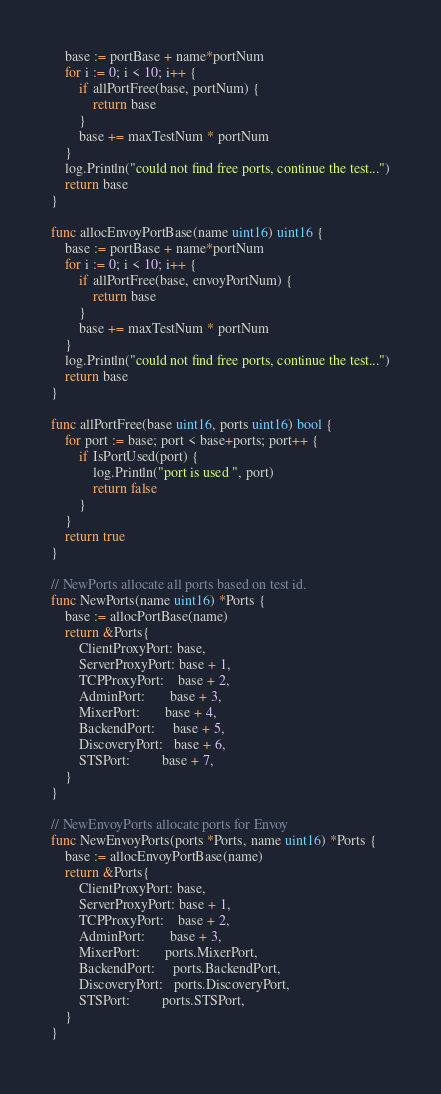Convert code to text. <code><loc_0><loc_0><loc_500><loc_500><_Go_>	base := portBase + name*portNum
	for i := 0; i < 10; i++ {
		if allPortFree(base, portNum) {
			return base
		}
		base += maxTestNum * portNum
	}
	log.Println("could not find free ports, continue the test...")
	return base
}

func allocEnvoyPortBase(name uint16) uint16 {
	base := portBase + name*portNum
	for i := 0; i < 10; i++ {
		if allPortFree(base, envoyPortNum) {
			return base
		}
		base += maxTestNum * portNum
	}
	log.Println("could not find free ports, continue the test...")
	return base
}

func allPortFree(base uint16, ports uint16) bool {
	for port := base; port < base+ports; port++ {
		if IsPortUsed(port) {
			log.Println("port is used ", port)
			return false
		}
	}
	return true
}

// NewPorts allocate all ports based on test id.
func NewPorts(name uint16) *Ports {
	base := allocPortBase(name)
	return &Ports{
		ClientProxyPort: base,
		ServerProxyPort: base + 1,
		TCPProxyPort:    base + 2,
		AdminPort:       base + 3,
		MixerPort:       base + 4,
		BackendPort:     base + 5,
		DiscoveryPort:   base + 6,
		STSPort:         base + 7,
	}
}

// NewEnvoyPorts allocate ports for Envoy
func NewEnvoyPorts(ports *Ports, name uint16) *Ports {
	base := allocEnvoyPortBase(name)
	return &Ports{
		ClientProxyPort: base,
		ServerProxyPort: base + 1,
		TCPProxyPort:    base + 2,
		AdminPort:       base + 3,
		MixerPort:       ports.MixerPort,
		BackendPort:     ports.BackendPort,
		DiscoveryPort:   ports.DiscoveryPort,
		STSPort:         ports.STSPort,
	}
}
</code> 